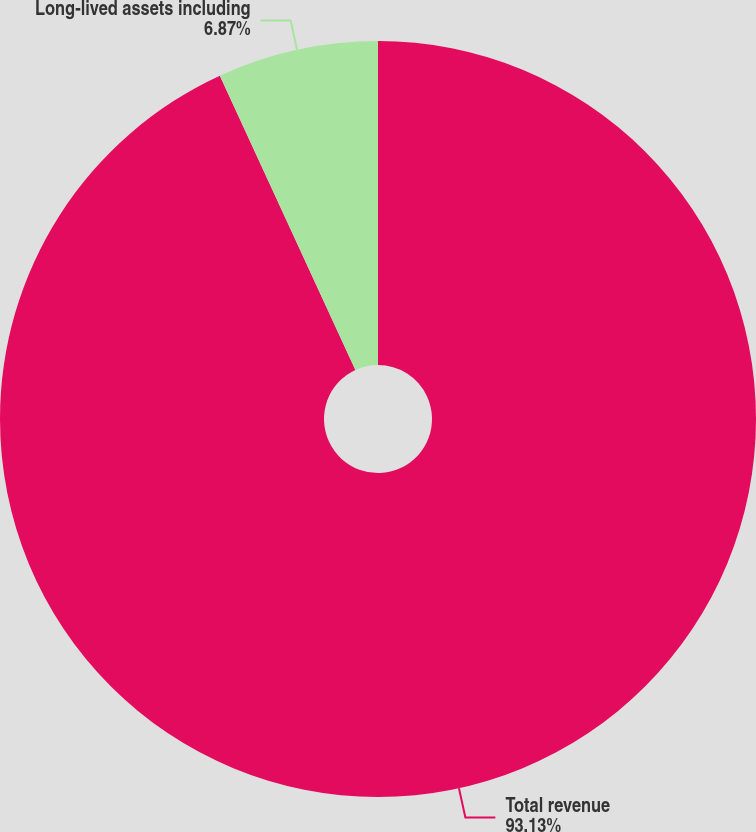Convert chart to OTSL. <chart><loc_0><loc_0><loc_500><loc_500><pie_chart><fcel>Total revenue<fcel>Long-lived assets including<nl><fcel>93.13%<fcel>6.87%<nl></chart> 